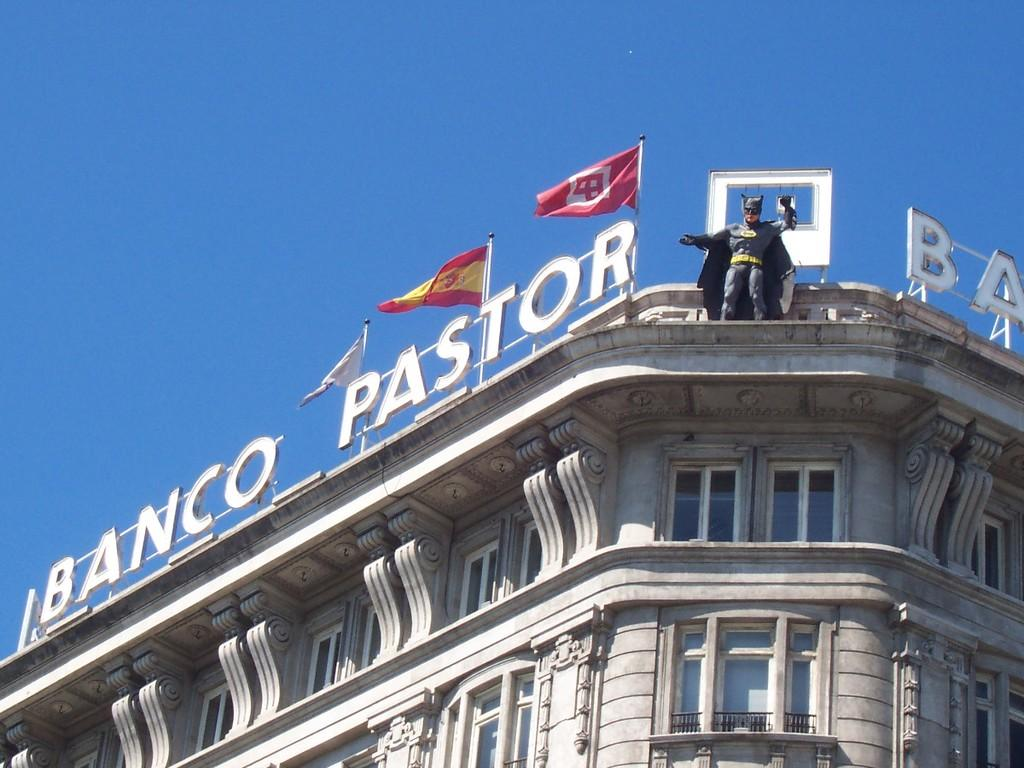What can be seen in the image that represents a country or organization? There are flags in the image that represent a country or organization. What structure in the image has a statue on it? There is a statue on a building in the image. What type of transport can be seen in the image? There is no transport visible in the image. What letter is written on the statue in the image? There is no letter written on the statue in the image. 